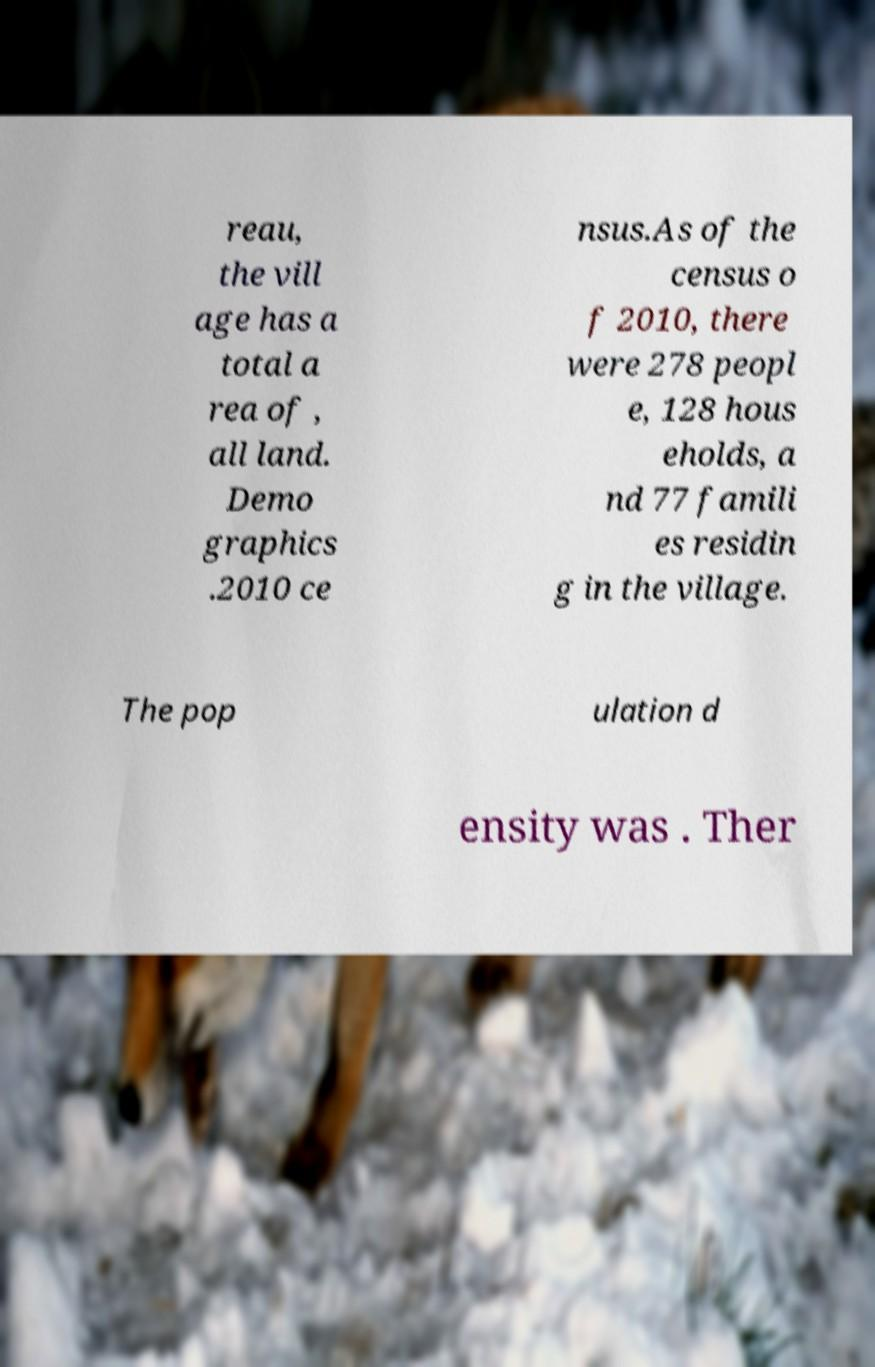Can you accurately transcribe the text from the provided image for me? reau, the vill age has a total a rea of , all land. Demo graphics .2010 ce nsus.As of the census o f 2010, there were 278 peopl e, 128 hous eholds, a nd 77 famili es residin g in the village. The pop ulation d ensity was . Ther 